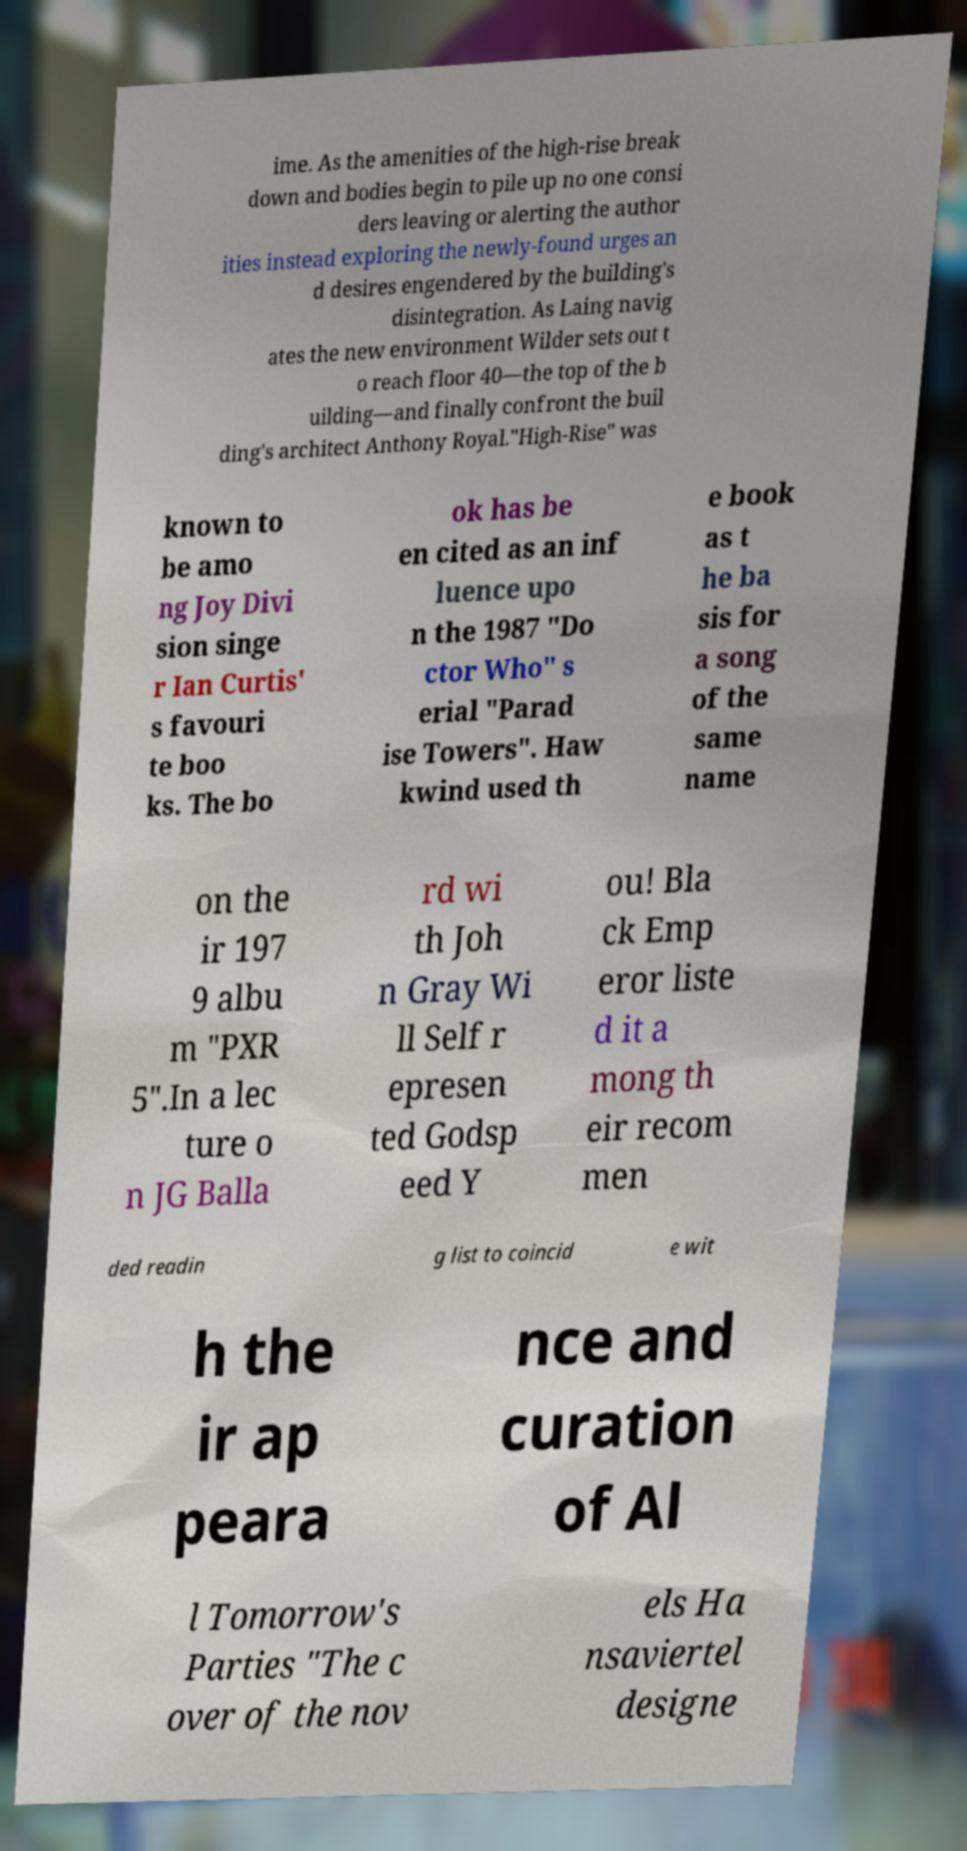I need the written content from this picture converted into text. Can you do that? ime. As the amenities of the high-rise break down and bodies begin to pile up no one consi ders leaving or alerting the author ities instead exploring the newly-found urges an d desires engendered by the building's disintegration. As Laing navig ates the new environment Wilder sets out t o reach floor 40—the top of the b uilding—and finally confront the buil ding's architect Anthony Royal."High-Rise" was known to be amo ng Joy Divi sion singe r Ian Curtis' s favouri te boo ks. The bo ok has be en cited as an inf luence upo n the 1987 "Do ctor Who" s erial "Parad ise Towers". Haw kwind used th e book as t he ba sis for a song of the same name on the ir 197 9 albu m "PXR 5".In a lec ture o n JG Balla rd wi th Joh n Gray Wi ll Self r epresen ted Godsp eed Y ou! Bla ck Emp eror liste d it a mong th eir recom men ded readin g list to coincid e wit h the ir ap peara nce and curation of Al l Tomorrow's Parties "The c over of the nov els Ha nsaviertel designe 